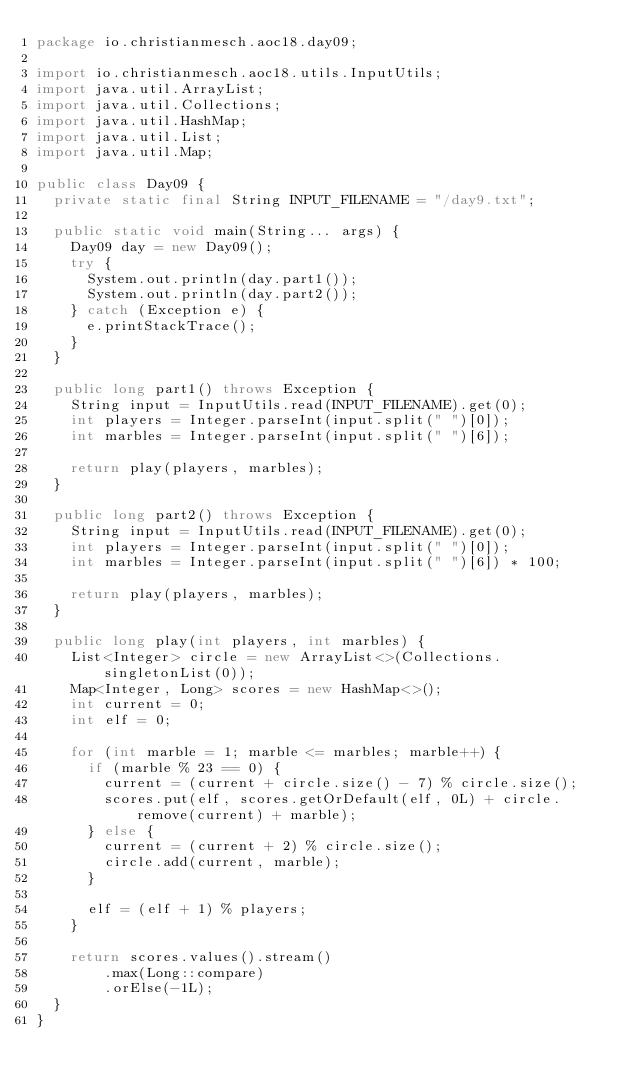Convert code to text. <code><loc_0><loc_0><loc_500><loc_500><_Java_>package io.christianmesch.aoc18.day09;

import io.christianmesch.aoc18.utils.InputUtils;
import java.util.ArrayList;
import java.util.Collections;
import java.util.HashMap;
import java.util.List;
import java.util.Map;

public class Day09 {
  private static final String INPUT_FILENAME = "/day9.txt";

  public static void main(String... args) {
    Day09 day = new Day09();
    try {
      System.out.println(day.part1());
      System.out.println(day.part2());
    } catch (Exception e) {
      e.printStackTrace();
    }
  }

  public long part1() throws Exception {
    String input = InputUtils.read(INPUT_FILENAME).get(0);
    int players = Integer.parseInt(input.split(" ")[0]);
    int marbles = Integer.parseInt(input.split(" ")[6]);

    return play(players, marbles);
  }

  public long part2() throws Exception {
    String input = InputUtils.read(INPUT_FILENAME).get(0);
    int players = Integer.parseInt(input.split(" ")[0]);
    int marbles = Integer.parseInt(input.split(" ")[6]) * 100;

    return play(players, marbles);
  }

  public long play(int players, int marbles) {
    List<Integer> circle = new ArrayList<>(Collections.singletonList(0));
    Map<Integer, Long> scores = new HashMap<>();
    int current = 0;
    int elf = 0;

    for (int marble = 1; marble <= marbles; marble++) {
      if (marble % 23 == 0) {
        current = (current + circle.size() - 7) % circle.size();
        scores.put(elf, scores.getOrDefault(elf, 0L) + circle.remove(current) + marble);
      } else {
        current = (current + 2) % circle.size();
        circle.add(current, marble);
      }

      elf = (elf + 1) % players;
    }

    return scores.values().stream()
        .max(Long::compare)
        .orElse(-1L);
  }
}</code> 